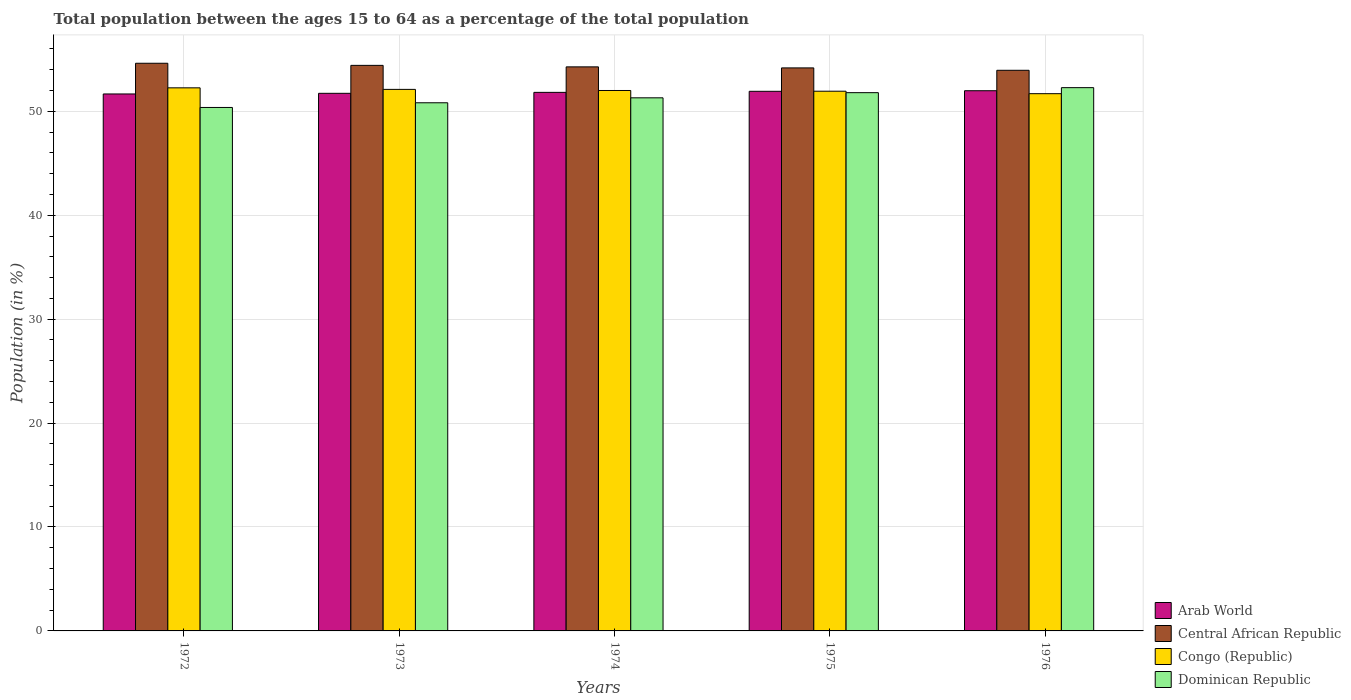How many different coloured bars are there?
Provide a succinct answer. 4. How many bars are there on the 4th tick from the right?
Provide a succinct answer. 4. What is the label of the 5th group of bars from the left?
Make the answer very short. 1976. In how many cases, is the number of bars for a given year not equal to the number of legend labels?
Offer a terse response. 0. What is the percentage of the population ages 15 to 64 in Congo (Republic) in 1973?
Your answer should be very brief. 52.11. Across all years, what is the maximum percentage of the population ages 15 to 64 in Central African Republic?
Provide a short and direct response. 54.62. Across all years, what is the minimum percentage of the population ages 15 to 64 in Arab World?
Offer a very short reply. 51.67. In which year was the percentage of the population ages 15 to 64 in Arab World maximum?
Offer a very short reply. 1976. In which year was the percentage of the population ages 15 to 64 in Arab World minimum?
Provide a short and direct response. 1972. What is the total percentage of the population ages 15 to 64 in Central African Republic in the graph?
Make the answer very short. 271.44. What is the difference between the percentage of the population ages 15 to 64 in Dominican Republic in 1975 and that in 1976?
Offer a very short reply. -0.48. What is the difference between the percentage of the population ages 15 to 64 in Dominican Republic in 1973 and the percentage of the population ages 15 to 64 in Central African Republic in 1976?
Provide a short and direct response. -3.13. What is the average percentage of the population ages 15 to 64 in Dominican Republic per year?
Provide a succinct answer. 51.31. In the year 1975, what is the difference between the percentage of the population ages 15 to 64 in Dominican Republic and percentage of the population ages 15 to 64 in Central African Republic?
Your answer should be compact. -2.38. What is the ratio of the percentage of the population ages 15 to 64 in Dominican Republic in 1973 to that in 1974?
Provide a short and direct response. 0.99. What is the difference between the highest and the second highest percentage of the population ages 15 to 64 in Congo (Republic)?
Make the answer very short. 0.15. What is the difference between the highest and the lowest percentage of the population ages 15 to 64 in Congo (Republic)?
Make the answer very short. 0.56. In how many years, is the percentage of the population ages 15 to 64 in Arab World greater than the average percentage of the population ages 15 to 64 in Arab World taken over all years?
Offer a terse response. 2. Is it the case that in every year, the sum of the percentage of the population ages 15 to 64 in Arab World and percentage of the population ages 15 to 64 in Dominican Republic is greater than the sum of percentage of the population ages 15 to 64 in Congo (Republic) and percentage of the population ages 15 to 64 in Central African Republic?
Provide a short and direct response. No. What does the 3rd bar from the left in 1973 represents?
Give a very brief answer. Congo (Republic). What does the 3rd bar from the right in 1973 represents?
Give a very brief answer. Central African Republic. Is it the case that in every year, the sum of the percentage of the population ages 15 to 64 in Congo (Republic) and percentage of the population ages 15 to 64 in Central African Republic is greater than the percentage of the population ages 15 to 64 in Dominican Republic?
Your answer should be compact. Yes. How many years are there in the graph?
Offer a terse response. 5. Are the values on the major ticks of Y-axis written in scientific E-notation?
Make the answer very short. No. Does the graph contain any zero values?
Ensure brevity in your answer.  No. Where does the legend appear in the graph?
Your answer should be very brief. Bottom right. How many legend labels are there?
Keep it short and to the point. 4. What is the title of the graph?
Provide a short and direct response. Total population between the ages 15 to 64 as a percentage of the total population. What is the label or title of the Y-axis?
Ensure brevity in your answer.  Population (in %). What is the Population (in %) of Arab World in 1972?
Give a very brief answer. 51.67. What is the Population (in %) of Central African Republic in 1972?
Offer a terse response. 54.62. What is the Population (in %) of Congo (Republic) in 1972?
Your answer should be very brief. 52.26. What is the Population (in %) in Dominican Republic in 1972?
Make the answer very short. 50.37. What is the Population (in %) of Arab World in 1973?
Provide a short and direct response. 51.73. What is the Population (in %) in Central African Republic in 1973?
Your answer should be very brief. 54.42. What is the Population (in %) in Congo (Republic) in 1973?
Your answer should be compact. 52.11. What is the Population (in %) of Dominican Republic in 1973?
Provide a succinct answer. 50.82. What is the Population (in %) of Arab World in 1974?
Make the answer very short. 51.82. What is the Population (in %) in Central African Republic in 1974?
Offer a terse response. 54.28. What is the Population (in %) of Congo (Republic) in 1974?
Offer a terse response. 52. What is the Population (in %) of Dominican Republic in 1974?
Ensure brevity in your answer.  51.3. What is the Population (in %) in Arab World in 1975?
Your answer should be very brief. 51.92. What is the Population (in %) in Central African Republic in 1975?
Offer a very short reply. 54.17. What is the Population (in %) in Congo (Republic) in 1975?
Make the answer very short. 51.93. What is the Population (in %) in Dominican Republic in 1975?
Offer a terse response. 51.79. What is the Population (in %) in Arab World in 1976?
Provide a succinct answer. 51.98. What is the Population (in %) of Central African Republic in 1976?
Provide a short and direct response. 53.95. What is the Population (in %) of Congo (Republic) in 1976?
Offer a terse response. 51.69. What is the Population (in %) of Dominican Republic in 1976?
Provide a succinct answer. 52.27. Across all years, what is the maximum Population (in %) in Arab World?
Your answer should be very brief. 51.98. Across all years, what is the maximum Population (in %) of Central African Republic?
Your response must be concise. 54.62. Across all years, what is the maximum Population (in %) in Congo (Republic)?
Make the answer very short. 52.26. Across all years, what is the maximum Population (in %) of Dominican Republic?
Make the answer very short. 52.27. Across all years, what is the minimum Population (in %) of Arab World?
Provide a short and direct response. 51.67. Across all years, what is the minimum Population (in %) in Central African Republic?
Your answer should be compact. 53.95. Across all years, what is the minimum Population (in %) of Congo (Republic)?
Provide a short and direct response. 51.69. Across all years, what is the minimum Population (in %) in Dominican Republic?
Offer a very short reply. 50.37. What is the total Population (in %) in Arab World in the graph?
Your answer should be very brief. 259.12. What is the total Population (in %) in Central African Republic in the graph?
Provide a short and direct response. 271.44. What is the total Population (in %) in Congo (Republic) in the graph?
Provide a succinct answer. 259.99. What is the total Population (in %) of Dominican Republic in the graph?
Offer a very short reply. 256.55. What is the difference between the Population (in %) in Arab World in 1972 and that in 1973?
Keep it short and to the point. -0.06. What is the difference between the Population (in %) of Central African Republic in 1972 and that in 1973?
Make the answer very short. 0.2. What is the difference between the Population (in %) in Congo (Republic) in 1972 and that in 1973?
Your response must be concise. 0.15. What is the difference between the Population (in %) in Dominican Republic in 1972 and that in 1973?
Give a very brief answer. -0.45. What is the difference between the Population (in %) of Arab World in 1972 and that in 1974?
Ensure brevity in your answer.  -0.15. What is the difference between the Population (in %) in Central African Republic in 1972 and that in 1974?
Provide a short and direct response. 0.35. What is the difference between the Population (in %) in Congo (Republic) in 1972 and that in 1974?
Provide a short and direct response. 0.26. What is the difference between the Population (in %) in Dominican Republic in 1972 and that in 1974?
Ensure brevity in your answer.  -0.93. What is the difference between the Population (in %) of Arab World in 1972 and that in 1975?
Provide a short and direct response. -0.25. What is the difference between the Population (in %) of Central African Republic in 1972 and that in 1975?
Offer a very short reply. 0.45. What is the difference between the Population (in %) in Congo (Republic) in 1972 and that in 1975?
Make the answer very short. 0.32. What is the difference between the Population (in %) of Dominican Republic in 1972 and that in 1975?
Make the answer very short. -1.42. What is the difference between the Population (in %) of Arab World in 1972 and that in 1976?
Make the answer very short. -0.31. What is the difference between the Population (in %) in Central African Republic in 1972 and that in 1976?
Make the answer very short. 0.68. What is the difference between the Population (in %) of Congo (Republic) in 1972 and that in 1976?
Provide a short and direct response. 0.56. What is the difference between the Population (in %) in Dominican Republic in 1972 and that in 1976?
Your answer should be compact. -1.91. What is the difference between the Population (in %) in Arab World in 1973 and that in 1974?
Your answer should be very brief. -0.09. What is the difference between the Population (in %) in Central African Republic in 1973 and that in 1974?
Keep it short and to the point. 0.14. What is the difference between the Population (in %) of Congo (Republic) in 1973 and that in 1974?
Your answer should be very brief. 0.11. What is the difference between the Population (in %) in Dominican Republic in 1973 and that in 1974?
Keep it short and to the point. -0.48. What is the difference between the Population (in %) of Arab World in 1973 and that in 1975?
Your answer should be compact. -0.19. What is the difference between the Population (in %) in Central African Republic in 1973 and that in 1975?
Your answer should be compact. 0.24. What is the difference between the Population (in %) in Congo (Republic) in 1973 and that in 1975?
Your answer should be very brief. 0.18. What is the difference between the Population (in %) in Dominican Republic in 1973 and that in 1975?
Make the answer very short. -0.97. What is the difference between the Population (in %) of Arab World in 1973 and that in 1976?
Your answer should be very brief. -0.25. What is the difference between the Population (in %) in Central African Republic in 1973 and that in 1976?
Your answer should be compact. 0.47. What is the difference between the Population (in %) in Congo (Republic) in 1973 and that in 1976?
Give a very brief answer. 0.41. What is the difference between the Population (in %) in Dominican Republic in 1973 and that in 1976?
Offer a very short reply. -1.45. What is the difference between the Population (in %) of Arab World in 1974 and that in 1975?
Ensure brevity in your answer.  -0.1. What is the difference between the Population (in %) in Central African Republic in 1974 and that in 1975?
Offer a terse response. 0.1. What is the difference between the Population (in %) in Congo (Republic) in 1974 and that in 1975?
Your answer should be very brief. 0.07. What is the difference between the Population (in %) of Dominican Republic in 1974 and that in 1975?
Provide a short and direct response. -0.5. What is the difference between the Population (in %) in Arab World in 1974 and that in 1976?
Give a very brief answer. -0.16. What is the difference between the Population (in %) in Central African Republic in 1974 and that in 1976?
Your answer should be compact. 0.33. What is the difference between the Population (in %) of Congo (Republic) in 1974 and that in 1976?
Make the answer very short. 0.31. What is the difference between the Population (in %) in Dominican Republic in 1974 and that in 1976?
Keep it short and to the point. -0.98. What is the difference between the Population (in %) in Arab World in 1975 and that in 1976?
Provide a short and direct response. -0.06. What is the difference between the Population (in %) in Central African Republic in 1975 and that in 1976?
Offer a very short reply. 0.23. What is the difference between the Population (in %) in Congo (Republic) in 1975 and that in 1976?
Give a very brief answer. 0.24. What is the difference between the Population (in %) in Dominican Republic in 1975 and that in 1976?
Make the answer very short. -0.48. What is the difference between the Population (in %) in Arab World in 1972 and the Population (in %) in Central African Republic in 1973?
Provide a succinct answer. -2.75. What is the difference between the Population (in %) of Arab World in 1972 and the Population (in %) of Congo (Republic) in 1973?
Your response must be concise. -0.44. What is the difference between the Population (in %) of Arab World in 1972 and the Population (in %) of Dominican Republic in 1973?
Make the answer very short. 0.85. What is the difference between the Population (in %) of Central African Republic in 1972 and the Population (in %) of Congo (Republic) in 1973?
Your answer should be very brief. 2.51. What is the difference between the Population (in %) of Central African Republic in 1972 and the Population (in %) of Dominican Republic in 1973?
Make the answer very short. 3.8. What is the difference between the Population (in %) of Congo (Republic) in 1972 and the Population (in %) of Dominican Republic in 1973?
Your response must be concise. 1.44. What is the difference between the Population (in %) of Arab World in 1972 and the Population (in %) of Central African Republic in 1974?
Make the answer very short. -2.61. What is the difference between the Population (in %) in Arab World in 1972 and the Population (in %) in Congo (Republic) in 1974?
Provide a succinct answer. -0.33. What is the difference between the Population (in %) in Arab World in 1972 and the Population (in %) in Dominican Republic in 1974?
Your answer should be very brief. 0.37. What is the difference between the Population (in %) in Central African Republic in 1972 and the Population (in %) in Congo (Republic) in 1974?
Your answer should be compact. 2.62. What is the difference between the Population (in %) in Central African Republic in 1972 and the Population (in %) in Dominican Republic in 1974?
Ensure brevity in your answer.  3.33. What is the difference between the Population (in %) in Congo (Republic) in 1972 and the Population (in %) in Dominican Republic in 1974?
Your response must be concise. 0.96. What is the difference between the Population (in %) of Arab World in 1972 and the Population (in %) of Central African Republic in 1975?
Give a very brief answer. -2.51. What is the difference between the Population (in %) in Arab World in 1972 and the Population (in %) in Congo (Republic) in 1975?
Make the answer very short. -0.26. What is the difference between the Population (in %) in Arab World in 1972 and the Population (in %) in Dominican Republic in 1975?
Your response must be concise. -0.12. What is the difference between the Population (in %) of Central African Republic in 1972 and the Population (in %) of Congo (Republic) in 1975?
Provide a short and direct response. 2.69. What is the difference between the Population (in %) of Central African Republic in 1972 and the Population (in %) of Dominican Republic in 1975?
Your answer should be compact. 2.83. What is the difference between the Population (in %) in Congo (Republic) in 1972 and the Population (in %) in Dominican Republic in 1975?
Give a very brief answer. 0.46. What is the difference between the Population (in %) in Arab World in 1972 and the Population (in %) in Central African Republic in 1976?
Your answer should be very brief. -2.28. What is the difference between the Population (in %) of Arab World in 1972 and the Population (in %) of Congo (Republic) in 1976?
Offer a terse response. -0.03. What is the difference between the Population (in %) in Arab World in 1972 and the Population (in %) in Dominican Republic in 1976?
Provide a succinct answer. -0.61. What is the difference between the Population (in %) in Central African Republic in 1972 and the Population (in %) in Congo (Republic) in 1976?
Keep it short and to the point. 2.93. What is the difference between the Population (in %) in Central African Republic in 1972 and the Population (in %) in Dominican Republic in 1976?
Your answer should be compact. 2.35. What is the difference between the Population (in %) in Congo (Republic) in 1972 and the Population (in %) in Dominican Republic in 1976?
Provide a succinct answer. -0.02. What is the difference between the Population (in %) in Arab World in 1973 and the Population (in %) in Central African Republic in 1974?
Keep it short and to the point. -2.55. What is the difference between the Population (in %) of Arab World in 1973 and the Population (in %) of Congo (Republic) in 1974?
Make the answer very short. -0.27. What is the difference between the Population (in %) of Arab World in 1973 and the Population (in %) of Dominican Republic in 1974?
Your answer should be very brief. 0.43. What is the difference between the Population (in %) of Central African Republic in 1973 and the Population (in %) of Congo (Republic) in 1974?
Provide a succinct answer. 2.42. What is the difference between the Population (in %) in Central African Republic in 1973 and the Population (in %) in Dominican Republic in 1974?
Offer a very short reply. 3.12. What is the difference between the Population (in %) in Congo (Republic) in 1973 and the Population (in %) in Dominican Republic in 1974?
Keep it short and to the point. 0.81. What is the difference between the Population (in %) in Arab World in 1973 and the Population (in %) in Central African Republic in 1975?
Your response must be concise. -2.45. What is the difference between the Population (in %) of Arab World in 1973 and the Population (in %) of Congo (Republic) in 1975?
Ensure brevity in your answer.  -0.2. What is the difference between the Population (in %) of Arab World in 1973 and the Population (in %) of Dominican Republic in 1975?
Your answer should be compact. -0.06. What is the difference between the Population (in %) in Central African Republic in 1973 and the Population (in %) in Congo (Republic) in 1975?
Keep it short and to the point. 2.49. What is the difference between the Population (in %) in Central African Republic in 1973 and the Population (in %) in Dominican Republic in 1975?
Your response must be concise. 2.63. What is the difference between the Population (in %) of Congo (Republic) in 1973 and the Population (in %) of Dominican Republic in 1975?
Provide a succinct answer. 0.32. What is the difference between the Population (in %) of Arab World in 1973 and the Population (in %) of Central African Republic in 1976?
Your answer should be very brief. -2.22. What is the difference between the Population (in %) of Arab World in 1973 and the Population (in %) of Congo (Republic) in 1976?
Offer a terse response. 0.04. What is the difference between the Population (in %) in Arab World in 1973 and the Population (in %) in Dominican Republic in 1976?
Your answer should be very brief. -0.55. What is the difference between the Population (in %) of Central African Republic in 1973 and the Population (in %) of Congo (Republic) in 1976?
Make the answer very short. 2.73. What is the difference between the Population (in %) in Central African Republic in 1973 and the Population (in %) in Dominican Republic in 1976?
Make the answer very short. 2.14. What is the difference between the Population (in %) in Congo (Republic) in 1973 and the Population (in %) in Dominican Republic in 1976?
Keep it short and to the point. -0.17. What is the difference between the Population (in %) of Arab World in 1974 and the Population (in %) of Central African Republic in 1975?
Your answer should be very brief. -2.35. What is the difference between the Population (in %) in Arab World in 1974 and the Population (in %) in Congo (Republic) in 1975?
Provide a short and direct response. -0.11. What is the difference between the Population (in %) of Arab World in 1974 and the Population (in %) of Dominican Republic in 1975?
Make the answer very short. 0.03. What is the difference between the Population (in %) of Central African Republic in 1974 and the Population (in %) of Congo (Republic) in 1975?
Make the answer very short. 2.34. What is the difference between the Population (in %) of Central African Republic in 1974 and the Population (in %) of Dominican Republic in 1975?
Give a very brief answer. 2.48. What is the difference between the Population (in %) of Congo (Republic) in 1974 and the Population (in %) of Dominican Republic in 1975?
Your response must be concise. 0.21. What is the difference between the Population (in %) in Arab World in 1974 and the Population (in %) in Central African Republic in 1976?
Keep it short and to the point. -2.13. What is the difference between the Population (in %) in Arab World in 1974 and the Population (in %) in Congo (Republic) in 1976?
Your answer should be compact. 0.13. What is the difference between the Population (in %) in Arab World in 1974 and the Population (in %) in Dominican Republic in 1976?
Provide a short and direct response. -0.45. What is the difference between the Population (in %) in Central African Republic in 1974 and the Population (in %) in Congo (Republic) in 1976?
Your response must be concise. 2.58. What is the difference between the Population (in %) of Central African Republic in 1974 and the Population (in %) of Dominican Republic in 1976?
Keep it short and to the point. 2. What is the difference between the Population (in %) in Congo (Republic) in 1974 and the Population (in %) in Dominican Republic in 1976?
Offer a terse response. -0.27. What is the difference between the Population (in %) in Arab World in 1975 and the Population (in %) in Central African Republic in 1976?
Offer a terse response. -2.02. What is the difference between the Population (in %) in Arab World in 1975 and the Population (in %) in Congo (Republic) in 1976?
Keep it short and to the point. 0.23. What is the difference between the Population (in %) of Arab World in 1975 and the Population (in %) of Dominican Republic in 1976?
Your answer should be compact. -0.35. What is the difference between the Population (in %) in Central African Republic in 1975 and the Population (in %) in Congo (Republic) in 1976?
Make the answer very short. 2.48. What is the difference between the Population (in %) of Central African Republic in 1975 and the Population (in %) of Dominican Republic in 1976?
Provide a succinct answer. 1.9. What is the difference between the Population (in %) of Congo (Republic) in 1975 and the Population (in %) of Dominican Republic in 1976?
Provide a succinct answer. -0.34. What is the average Population (in %) of Arab World per year?
Provide a succinct answer. 51.82. What is the average Population (in %) of Central African Republic per year?
Your answer should be very brief. 54.29. What is the average Population (in %) in Congo (Republic) per year?
Give a very brief answer. 52. What is the average Population (in %) of Dominican Republic per year?
Provide a short and direct response. 51.31. In the year 1972, what is the difference between the Population (in %) of Arab World and Population (in %) of Central African Republic?
Your answer should be very brief. -2.95. In the year 1972, what is the difference between the Population (in %) in Arab World and Population (in %) in Congo (Republic)?
Provide a succinct answer. -0.59. In the year 1972, what is the difference between the Population (in %) of Arab World and Population (in %) of Dominican Republic?
Your answer should be very brief. 1.3. In the year 1972, what is the difference between the Population (in %) in Central African Republic and Population (in %) in Congo (Republic)?
Offer a very short reply. 2.37. In the year 1972, what is the difference between the Population (in %) in Central African Republic and Population (in %) in Dominican Republic?
Your response must be concise. 4.25. In the year 1972, what is the difference between the Population (in %) in Congo (Republic) and Population (in %) in Dominican Republic?
Your response must be concise. 1.89. In the year 1973, what is the difference between the Population (in %) in Arab World and Population (in %) in Central African Republic?
Offer a terse response. -2.69. In the year 1973, what is the difference between the Population (in %) of Arab World and Population (in %) of Congo (Republic)?
Give a very brief answer. -0.38. In the year 1973, what is the difference between the Population (in %) of Arab World and Population (in %) of Dominican Republic?
Your response must be concise. 0.91. In the year 1973, what is the difference between the Population (in %) of Central African Republic and Population (in %) of Congo (Republic)?
Provide a short and direct response. 2.31. In the year 1973, what is the difference between the Population (in %) of Central African Republic and Population (in %) of Dominican Republic?
Offer a very short reply. 3.6. In the year 1973, what is the difference between the Population (in %) of Congo (Republic) and Population (in %) of Dominican Republic?
Keep it short and to the point. 1.29. In the year 1974, what is the difference between the Population (in %) in Arab World and Population (in %) in Central African Republic?
Your response must be concise. -2.45. In the year 1974, what is the difference between the Population (in %) of Arab World and Population (in %) of Congo (Republic)?
Give a very brief answer. -0.18. In the year 1974, what is the difference between the Population (in %) of Arab World and Population (in %) of Dominican Republic?
Give a very brief answer. 0.52. In the year 1974, what is the difference between the Population (in %) of Central African Republic and Population (in %) of Congo (Republic)?
Provide a succinct answer. 2.27. In the year 1974, what is the difference between the Population (in %) in Central African Republic and Population (in %) in Dominican Republic?
Give a very brief answer. 2.98. In the year 1974, what is the difference between the Population (in %) in Congo (Republic) and Population (in %) in Dominican Republic?
Provide a succinct answer. 0.7. In the year 1975, what is the difference between the Population (in %) in Arab World and Population (in %) in Central African Republic?
Your response must be concise. -2.25. In the year 1975, what is the difference between the Population (in %) in Arab World and Population (in %) in Congo (Republic)?
Offer a terse response. -0.01. In the year 1975, what is the difference between the Population (in %) of Arab World and Population (in %) of Dominican Republic?
Your response must be concise. 0.13. In the year 1975, what is the difference between the Population (in %) of Central African Republic and Population (in %) of Congo (Republic)?
Your response must be concise. 2.24. In the year 1975, what is the difference between the Population (in %) of Central African Republic and Population (in %) of Dominican Republic?
Ensure brevity in your answer.  2.38. In the year 1975, what is the difference between the Population (in %) in Congo (Republic) and Population (in %) in Dominican Republic?
Provide a succinct answer. 0.14. In the year 1976, what is the difference between the Population (in %) in Arab World and Population (in %) in Central African Republic?
Offer a terse response. -1.97. In the year 1976, what is the difference between the Population (in %) in Arab World and Population (in %) in Congo (Republic)?
Offer a very short reply. 0.28. In the year 1976, what is the difference between the Population (in %) of Arab World and Population (in %) of Dominican Republic?
Offer a terse response. -0.3. In the year 1976, what is the difference between the Population (in %) of Central African Republic and Population (in %) of Congo (Republic)?
Provide a short and direct response. 2.25. In the year 1976, what is the difference between the Population (in %) in Central African Republic and Population (in %) in Dominican Republic?
Make the answer very short. 1.67. In the year 1976, what is the difference between the Population (in %) of Congo (Republic) and Population (in %) of Dominican Republic?
Offer a terse response. -0.58. What is the ratio of the Population (in %) of Arab World in 1972 to that in 1973?
Ensure brevity in your answer.  1. What is the ratio of the Population (in %) in Dominican Republic in 1972 to that in 1973?
Keep it short and to the point. 0.99. What is the ratio of the Population (in %) in Central African Republic in 1972 to that in 1974?
Ensure brevity in your answer.  1.01. What is the ratio of the Population (in %) of Congo (Republic) in 1972 to that in 1974?
Keep it short and to the point. 1. What is the ratio of the Population (in %) of Dominican Republic in 1972 to that in 1974?
Offer a very short reply. 0.98. What is the ratio of the Population (in %) in Arab World in 1972 to that in 1975?
Your response must be concise. 1. What is the ratio of the Population (in %) of Central African Republic in 1972 to that in 1975?
Offer a very short reply. 1.01. What is the ratio of the Population (in %) of Dominican Republic in 1972 to that in 1975?
Give a very brief answer. 0.97. What is the ratio of the Population (in %) of Arab World in 1972 to that in 1976?
Provide a short and direct response. 0.99. What is the ratio of the Population (in %) of Central African Republic in 1972 to that in 1976?
Provide a short and direct response. 1.01. What is the ratio of the Population (in %) in Congo (Republic) in 1972 to that in 1976?
Give a very brief answer. 1.01. What is the ratio of the Population (in %) of Dominican Republic in 1972 to that in 1976?
Your answer should be compact. 0.96. What is the ratio of the Population (in %) in Arab World in 1973 to that in 1974?
Keep it short and to the point. 1. What is the ratio of the Population (in %) in Congo (Republic) in 1973 to that in 1974?
Your answer should be very brief. 1. What is the ratio of the Population (in %) in Dominican Republic in 1973 to that in 1974?
Your answer should be compact. 0.99. What is the ratio of the Population (in %) in Central African Republic in 1973 to that in 1975?
Provide a succinct answer. 1. What is the ratio of the Population (in %) of Dominican Republic in 1973 to that in 1975?
Your answer should be very brief. 0.98. What is the ratio of the Population (in %) in Central African Republic in 1973 to that in 1976?
Your answer should be very brief. 1.01. What is the ratio of the Population (in %) of Dominican Republic in 1973 to that in 1976?
Keep it short and to the point. 0.97. What is the ratio of the Population (in %) in Arab World in 1974 to that in 1976?
Make the answer very short. 1. What is the ratio of the Population (in %) of Central African Republic in 1974 to that in 1976?
Make the answer very short. 1.01. What is the ratio of the Population (in %) of Congo (Republic) in 1974 to that in 1976?
Ensure brevity in your answer.  1.01. What is the ratio of the Population (in %) in Dominican Republic in 1974 to that in 1976?
Make the answer very short. 0.98. What is the ratio of the Population (in %) in Congo (Republic) in 1975 to that in 1976?
Your response must be concise. 1. What is the ratio of the Population (in %) of Dominican Republic in 1975 to that in 1976?
Offer a terse response. 0.99. What is the difference between the highest and the second highest Population (in %) in Arab World?
Offer a terse response. 0.06. What is the difference between the highest and the second highest Population (in %) in Central African Republic?
Provide a short and direct response. 0.2. What is the difference between the highest and the second highest Population (in %) in Congo (Republic)?
Keep it short and to the point. 0.15. What is the difference between the highest and the second highest Population (in %) of Dominican Republic?
Give a very brief answer. 0.48. What is the difference between the highest and the lowest Population (in %) of Arab World?
Provide a short and direct response. 0.31. What is the difference between the highest and the lowest Population (in %) of Central African Republic?
Make the answer very short. 0.68. What is the difference between the highest and the lowest Population (in %) of Congo (Republic)?
Your answer should be very brief. 0.56. What is the difference between the highest and the lowest Population (in %) of Dominican Republic?
Provide a short and direct response. 1.91. 